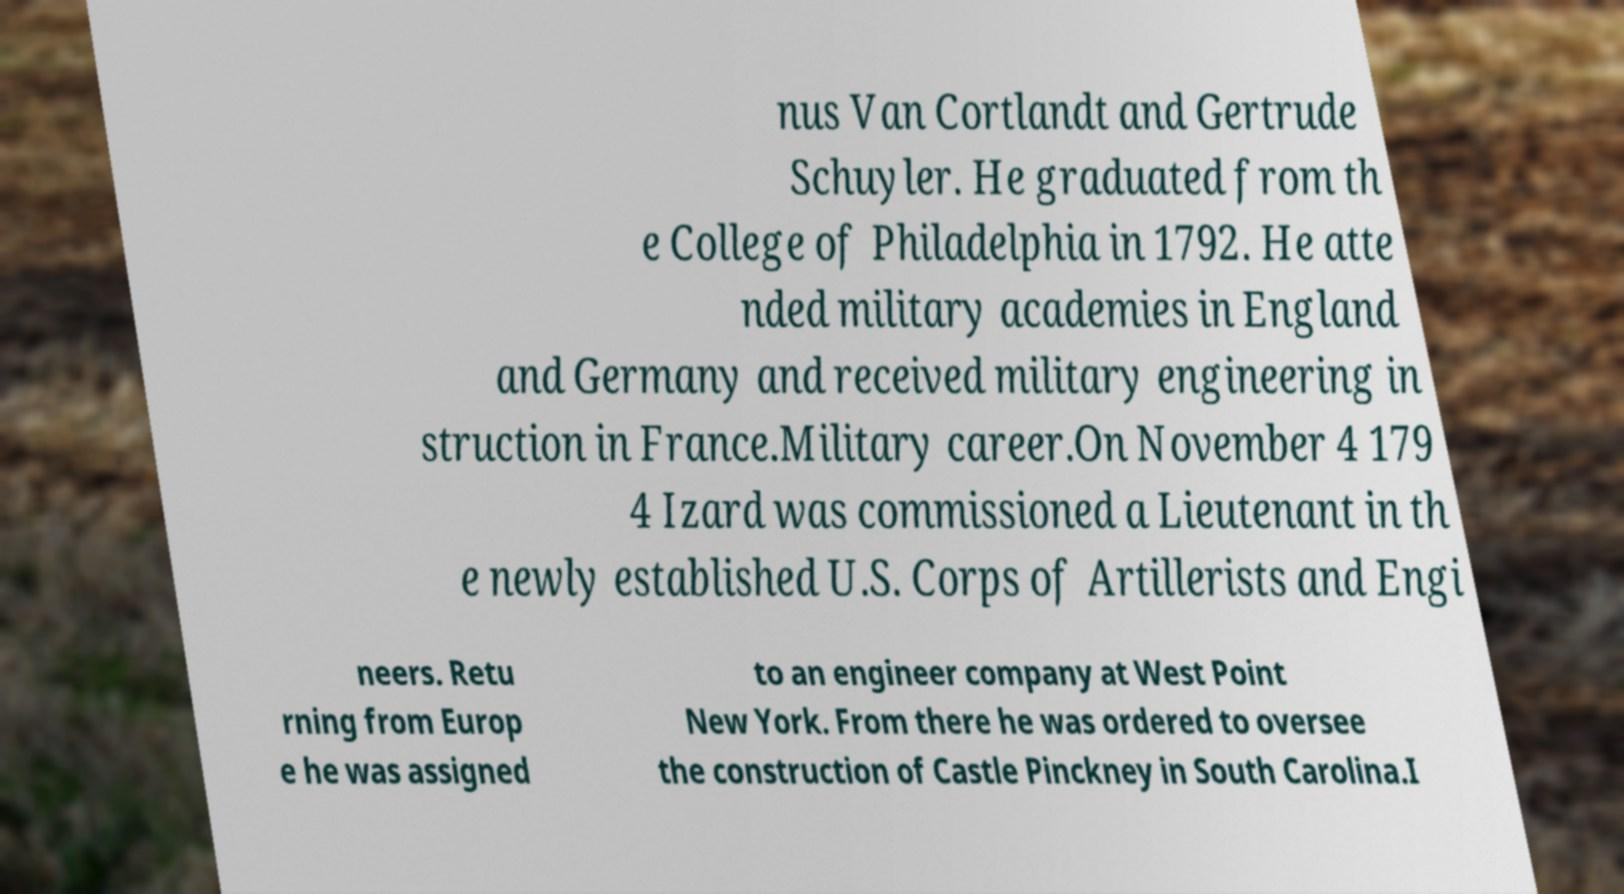For documentation purposes, I need the text within this image transcribed. Could you provide that? nus Van Cortlandt and Gertrude Schuyler. He graduated from th e College of Philadelphia in 1792. He atte nded military academies in England and Germany and received military engineering in struction in France.Military career.On November 4 179 4 Izard was commissioned a Lieutenant in th e newly established U.S. Corps of Artillerists and Engi neers. Retu rning from Europ e he was assigned to an engineer company at West Point New York. From there he was ordered to oversee the construction of Castle Pinckney in South Carolina.I 